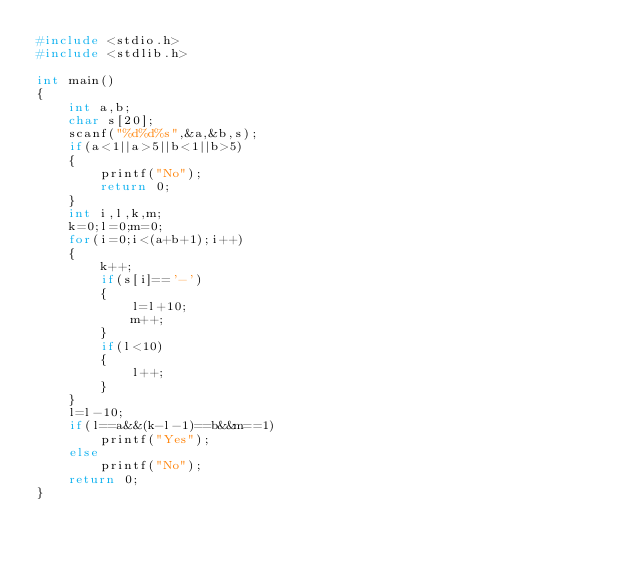Convert code to text. <code><loc_0><loc_0><loc_500><loc_500><_C_>#include <stdio.h>
#include <stdlib.h>

int main()
{
    int a,b;
    char s[20];
    scanf("%d%d%s",&a,&b,s);
    if(a<1||a>5||b<1||b>5)
    {
        printf("No");
        return 0;
    }
    int i,l,k,m;
    k=0;l=0;m=0;
    for(i=0;i<(a+b+1);i++)
    {
        k++;
        if(s[i]=='-')
        {
            l=l+10;
            m++;
        }
        if(l<10)
        {
            l++;
        }
    }
    l=l-10;
    if(l==a&&(k-l-1)==b&&m==1)
        printf("Yes");
    else
        printf("No");
    return 0;
}
</code> 